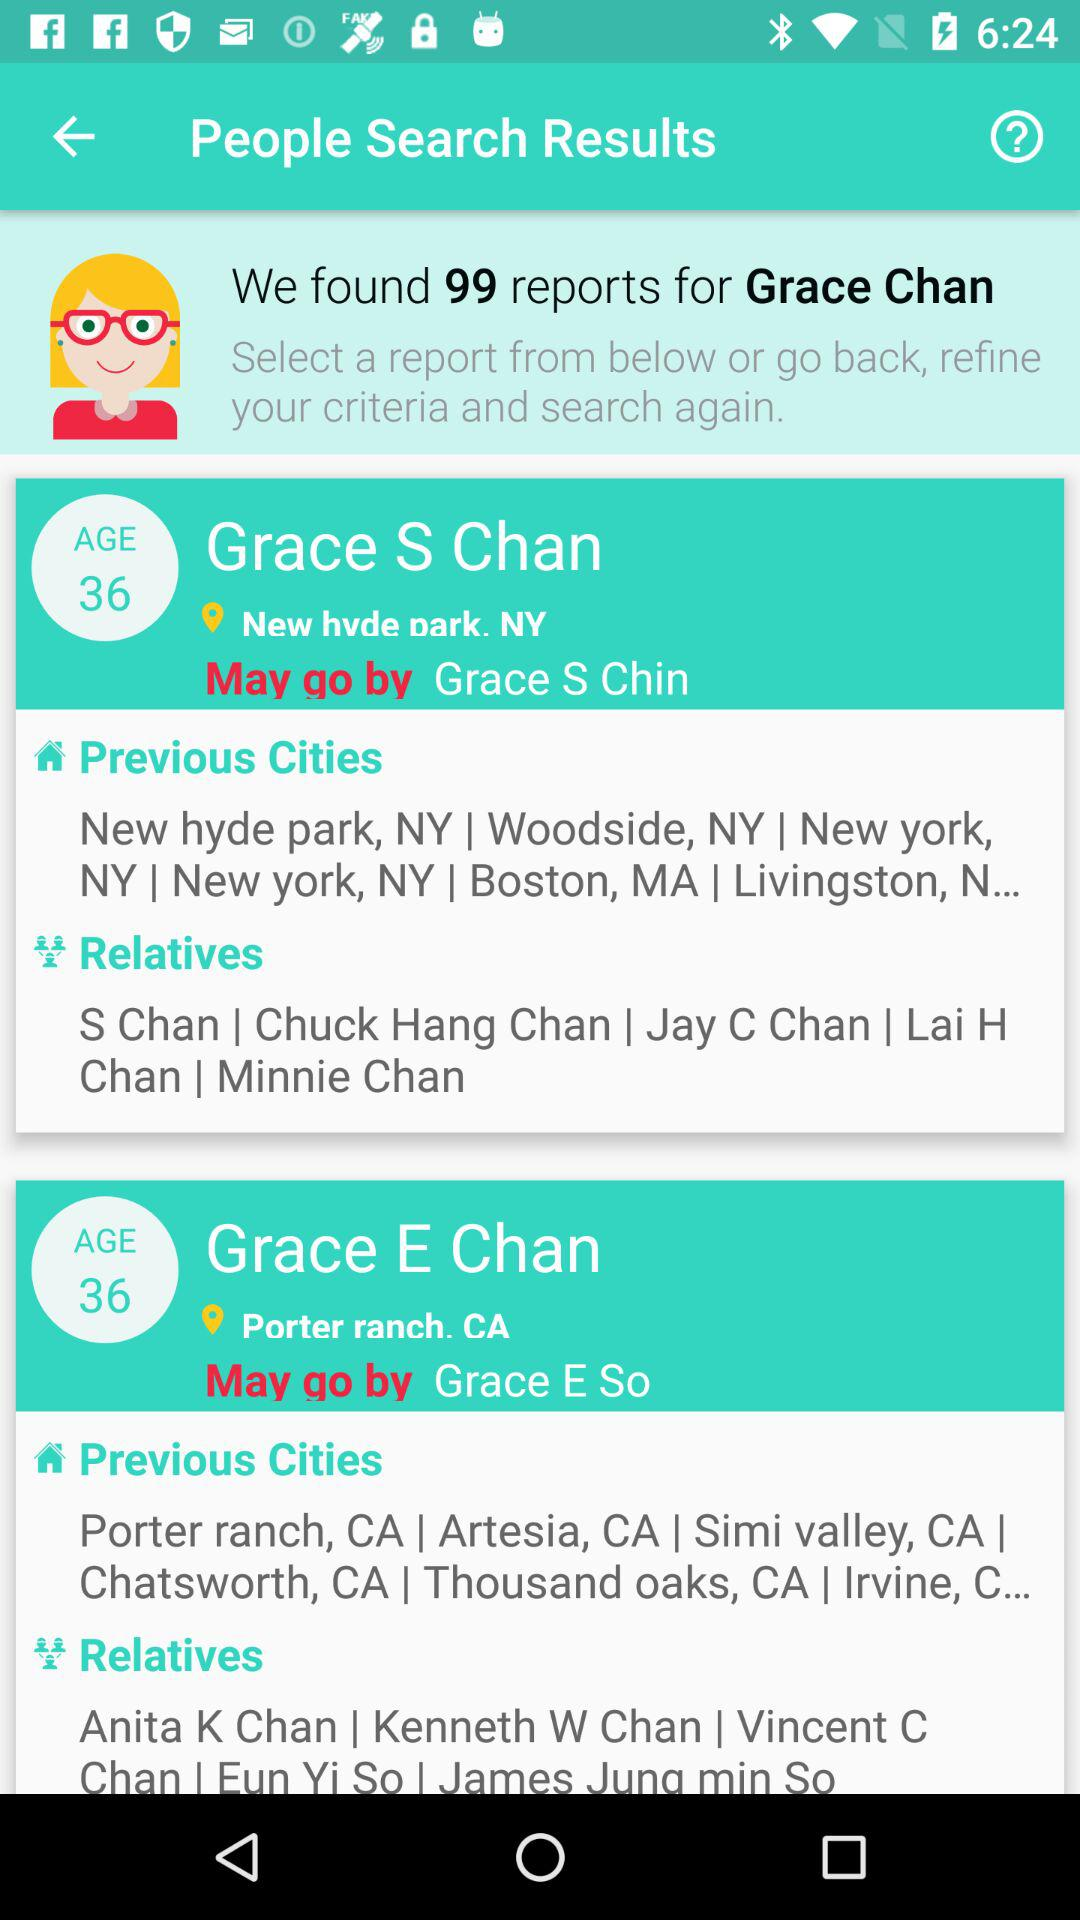What is the age of Grace S Chan? The age is 36. 